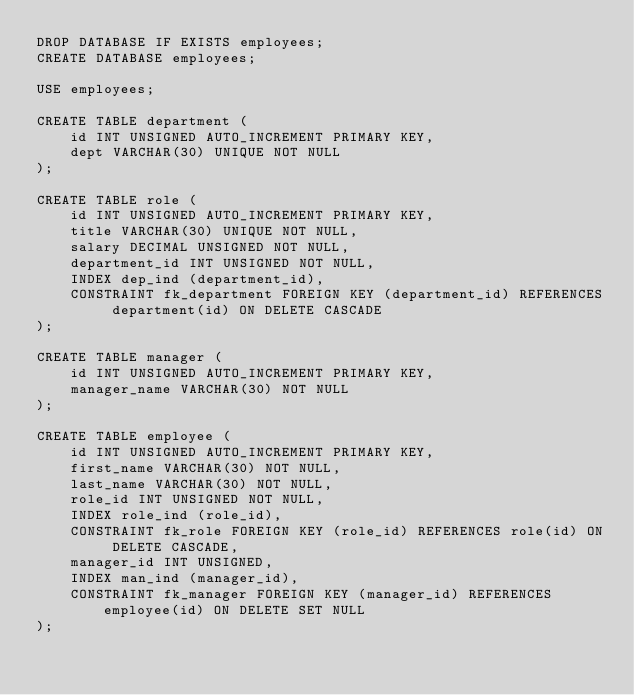Convert code to text. <code><loc_0><loc_0><loc_500><loc_500><_SQL_>DROP DATABASE IF EXISTS employees;
CREATE DATABASE employees;

USE employees;

CREATE TABLE department (
    id INT UNSIGNED AUTO_INCREMENT PRIMARY KEY,
    dept VARCHAR(30) UNIQUE NOT NULL
);

CREATE TABLE role (
    id INT UNSIGNED AUTO_INCREMENT PRIMARY KEY,
    title VARCHAR(30) UNIQUE NOT NULL,
    salary DECIMAL UNSIGNED NOT NULL,
    department_id INT UNSIGNED NOT NULL,
    INDEX dep_ind (department_id),
    CONSTRAINT fk_department FOREIGN KEY (department_id) REFERENCES department(id) ON DELETE CASCADE
);

CREATE TABLE manager (
    id INT UNSIGNED AUTO_INCREMENT PRIMARY KEY,
    manager_name VARCHAR(30) NOT NULL
);

CREATE TABLE employee (
    id INT UNSIGNED AUTO_INCREMENT PRIMARY KEY,
    first_name VARCHAR(30) NOT NULL,
    last_name VARCHAR(30) NOT NULL,
    role_id INT UNSIGNED NOT NULL,
    INDEX role_ind (role_id),
    CONSTRAINT fk_role FOREIGN KEY (role_id) REFERENCES role(id) ON DELETE CASCADE,
    manager_id INT UNSIGNED,
    INDEX man_ind (manager_id),
    CONSTRAINT fk_manager FOREIGN KEY (manager_id) REFERENCES employee(id) ON DELETE SET NULL
);</code> 